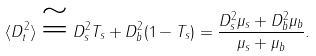<formula> <loc_0><loc_0><loc_500><loc_500>\langle D _ { t } ^ { 2 } \rangle \cong D _ { s } ^ { 2 } T _ { s } + D _ { b } ^ { 2 } ( 1 - T _ { s } ) = \frac { D ^ { 2 } _ { s } \mu _ { s } + D ^ { 2 } _ { b } \mu _ { b } } { \mu _ { s } + \mu _ { b } } .</formula> 